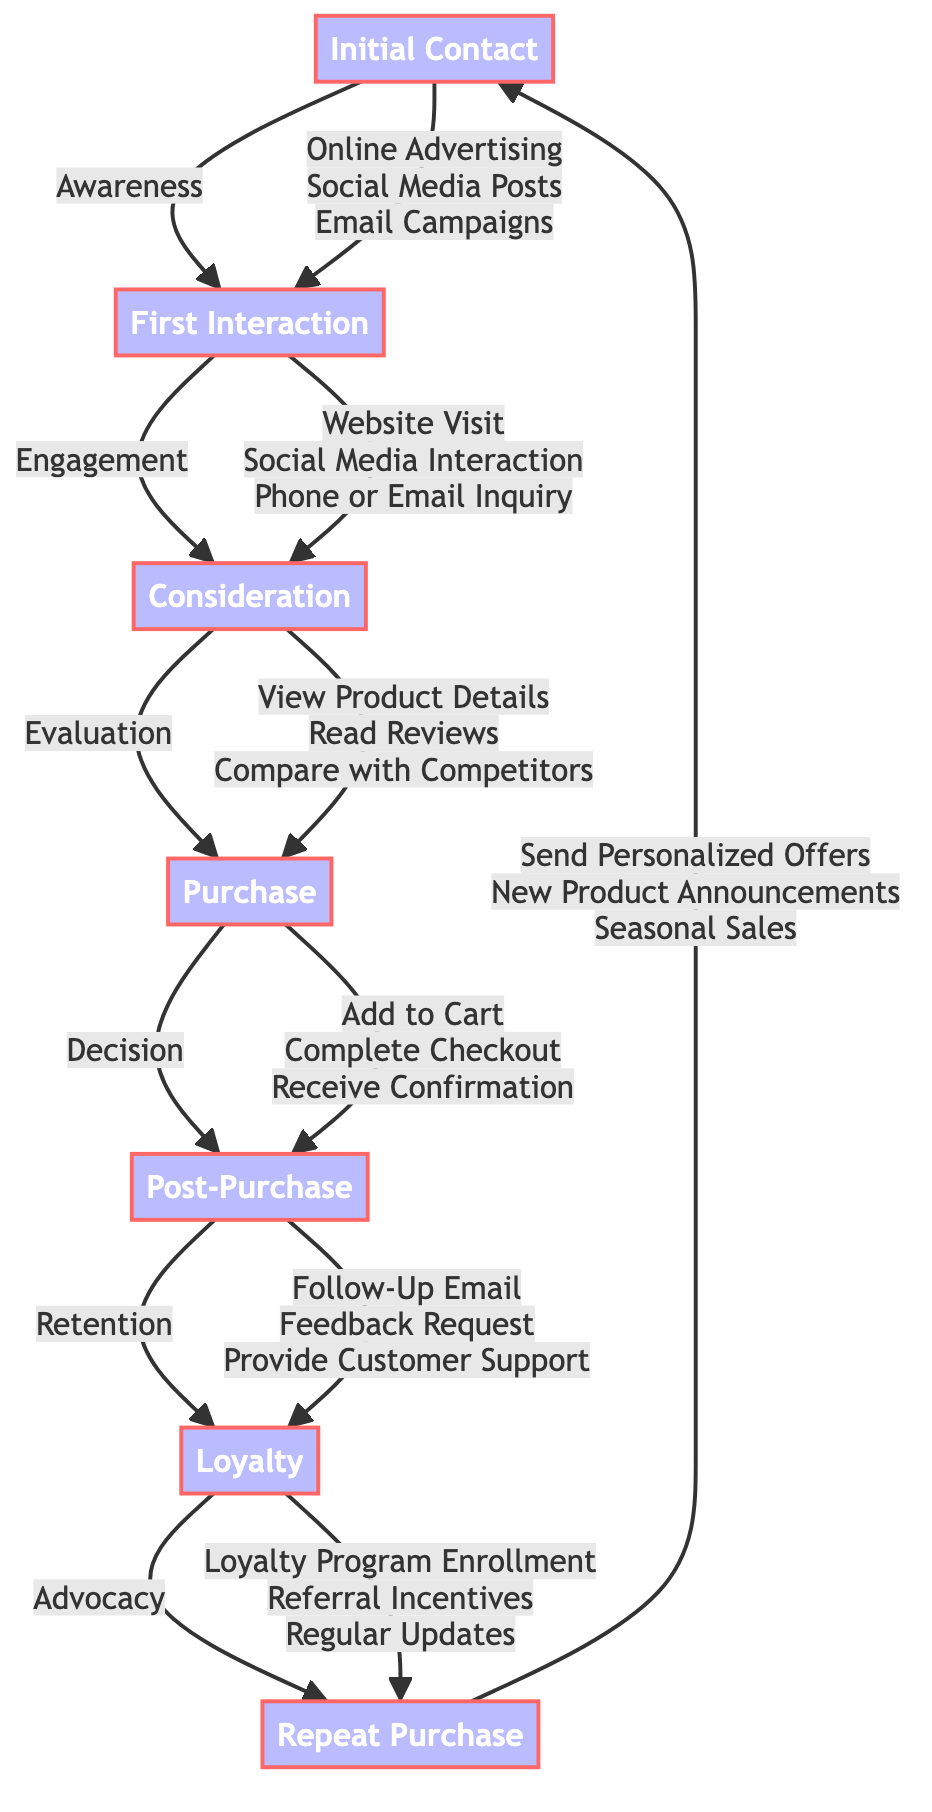what is the first stage in the customer journey? The first stage in the customer journey, as indicated in the diagram, is "Awareness," which is represented as the node after "Initial Contact."
Answer: Awareness how many actions are listed in the consideration stage? In the consideration stage, there are three actions specified: "View Product Details," "Read Reviews," and "Compare with Competitors." Therefore, the number of actions is three.
Answer: 3 what is the outcome of the post-purchase stage? The outcome of the post-purchase stage is defined in the diagram as "Maintain customer satisfaction and ensure any issues are resolved." This is the specific outcome described for that stage.
Answer: Maintain customer satisfaction and ensure any issues are resolved which stage follows the engagement stage? The stage that follows "Engagement" in the flowchart is "Evaluation." The arrows denote this progression from one stage to the next.
Answer: Evaluation what actions are involved in the loyalty stage? The actions listed for the loyalty stage include three activities: "Loyalty Program Enrollment," "Referral Incentives," and "Regular Updates." These actions are specified under the loyalty stage in the diagram.
Answer: Loyalty Program Enrollment, Referral Incentives, Regular Updates how many nodes are in the entire customer journey? The diagram depicts a total of seven nodes representing different stages in the customer journey, starting from "Initial Contact" to "Repeat Purchase."
Answer: 7 what do customers do during the purchase stage? During the purchase stage, customers perform three specific actions: "Add to Cart," "Complete Checkout," and "Receive Confirmation." These actions are clearly defined under that stage in the diagram.
Answer: Add to Cart, Complete Checkout, Receive Confirmation which stage is focused on customer advocacy? The stage that emphasizes customer advocacy is called "Advocacy," which is also referred to as the loyalty stage in the flowchart. This stage occurs after post-purchase.
Answer: Advocacy what tools are used in the first interaction stage? The tools or entities utilized in the first interaction stage are "Company Website," "Facebook Comments," and "Gmail." These entities are associated with that stage as per the diagram.
Answer: Company Website, Facebook Comments, Gmail 